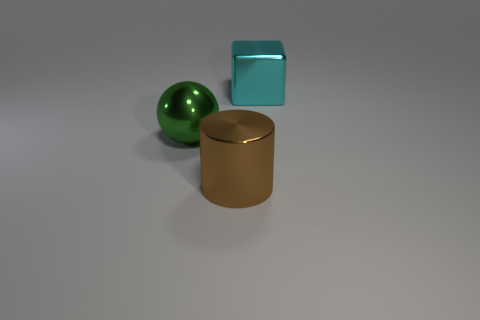Is the large green object made of the same material as the thing right of the cylinder?
Provide a short and direct response. Yes. Is the number of things that are behind the brown shiny cylinder less than the number of big brown things behind the large metal ball?
Offer a terse response. No. What is the big object to the left of the large brown object made of?
Provide a short and direct response. Metal. What is the color of the metal thing that is to the left of the large metal cube and behind the brown object?
Make the answer very short. Green. How many other objects are the same color as the big shiny sphere?
Give a very brief answer. 0. The metal object in front of the green metal object is what color?
Offer a very short reply. Brown. Is there a cyan shiny object that has the same size as the green metal ball?
Your answer should be very brief. Yes. There is a cyan cube that is the same size as the brown object; what material is it?
Your response must be concise. Metal. How many things are large objects right of the big brown thing or large metal things that are in front of the green ball?
Your response must be concise. 2. Is there a tiny purple rubber object that has the same shape as the large green thing?
Provide a short and direct response. No. 